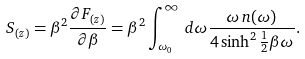Convert formula to latex. <formula><loc_0><loc_0><loc_500><loc_500>S _ { ( z ) } = \beta ^ { 2 } \frac { \partial F _ { ( z ) } } { \partial \beta } = \beta ^ { 2 } \int _ { \omega _ { 0 } } ^ { \infty } \, d \omega \frac { \omega \, n ( \omega ) } { 4 \sinh ^ { 2 } \frac { 1 } { 2 } \beta \omega } .</formula> 